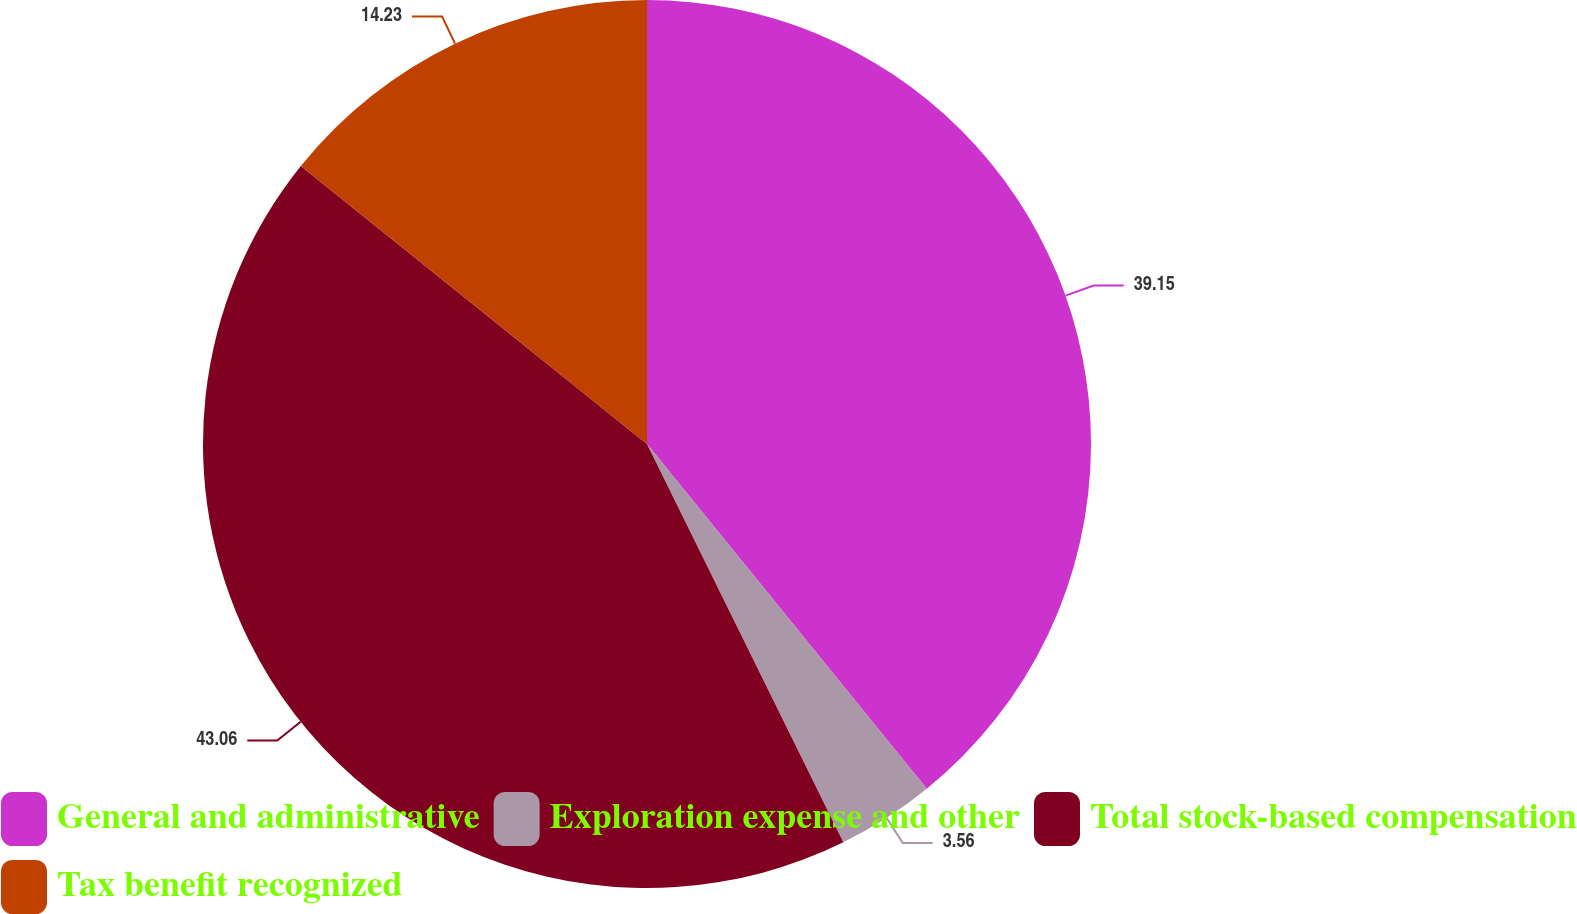<chart> <loc_0><loc_0><loc_500><loc_500><pie_chart><fcel>General and administrative<fcel>Exploration expense and other<fcel>Total stock-based compensation<fcel>Tax benefit recognized<nl><fcel>39.15%<fcel>3.56%<fcel>43.06%<fcel>14.23%<nl></chart> 